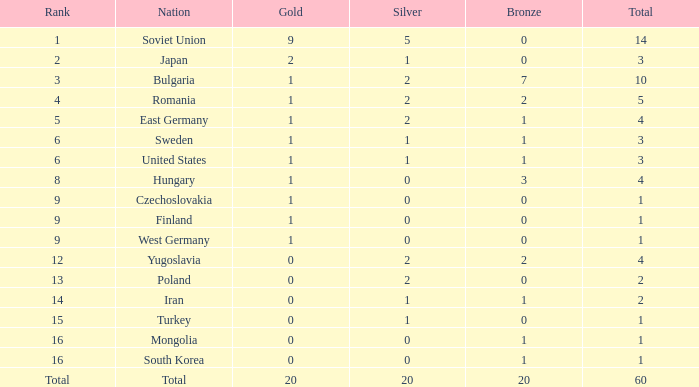What is the average silver for golds over 2, ranks of 1, and bronzes over 0? None. 